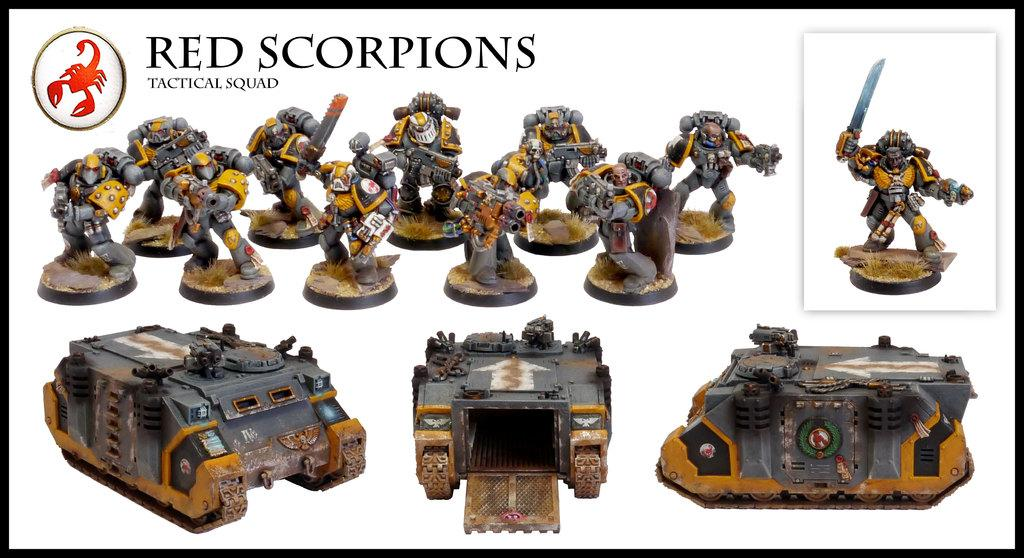What is the main subject of the poster in the image? The poster contains images of persons and vehicles as toys. Are there any specific features on the poster? Yes, there is a logo and text on the poster. What type of rod can be seen holding up the poster in the image? There is no rod present in the image. 